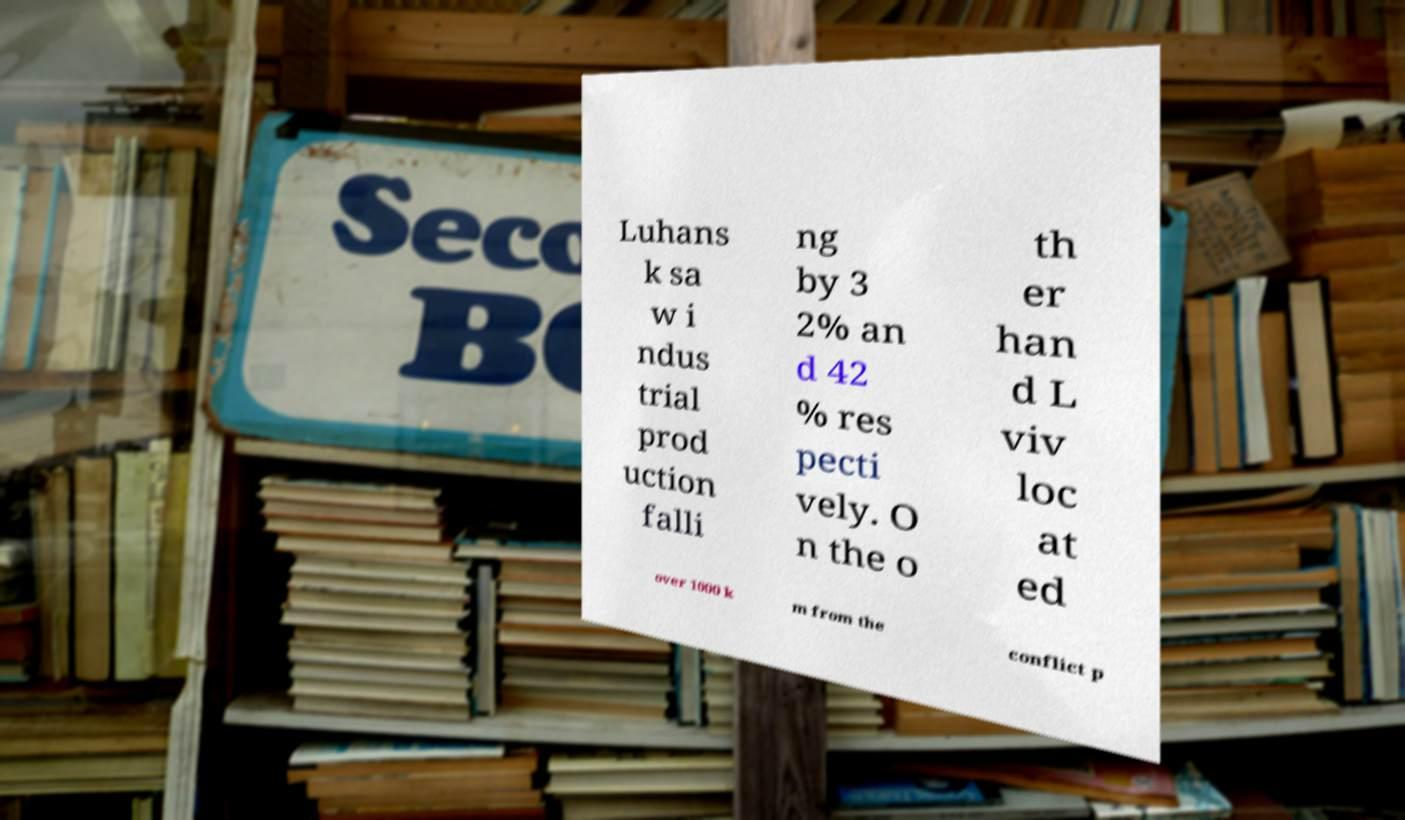I need the written content from this picture converted into text. Can you do that? Luhans k sa w i ndus trial prod uction falli ng by 3 2% an d 42 % res pecti vely. O n the o th er han d L viv loc at ed over 1000 k m from the conflict p 